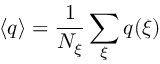<formula> <loc_0><loc_0><loc_500><loc_500>\langle q \rangle = \frac { 1 } { N _ { \xi } } \sum _ { \xi } q ( \xi )</formula> 